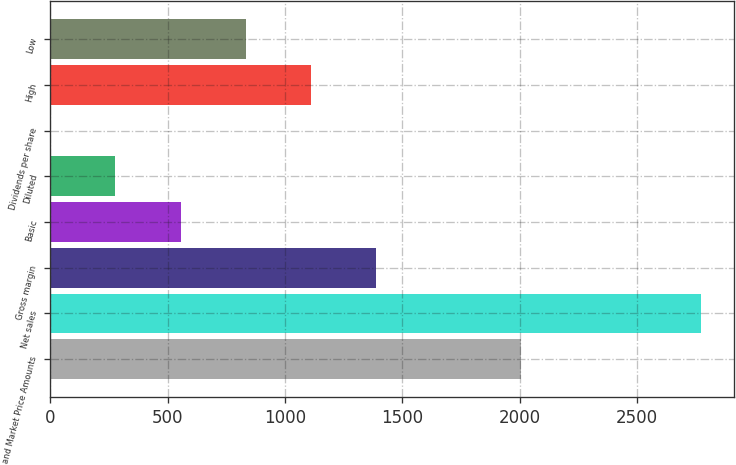Convert chart. <chart><loc_0><loc_0><loc_500><loc_500><bar_chart><fcel>and Market Price Amounts<fcel>Net sales<fcel>Gross margin<fcel>Basic<fcel>Diluted<fcel>Dividends per share<fcel>High<fcel>Low<nl><fcel>2005<fcel>2772<fcel>1386.19<fcel>554.68<fcel>277.51<fcel>0.34<fcel>1109.02<fcel>831.85<nl></chart> 